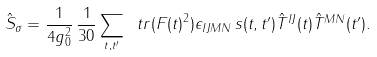Convert formula to latex. <formula><loc_0><loc_0><loc_500><loc_500>\hat { S } _ { \sigma } = \frac { 1 } { 4 g _ { 0 } ^ { 2 } } \, \frac { 1 } { 3 0 } \sum _ { t , t ^ { \prime } } \ t r ( { F ( t ) } ^ { 2 } ) \epsilon _ { I J M N } \, s ( t , t ^ { \prime } ) \hat { T } ^ { I J } ( t ) \hat { T } ^ { M N } ( t ^ { \prime } ) .</formula> 